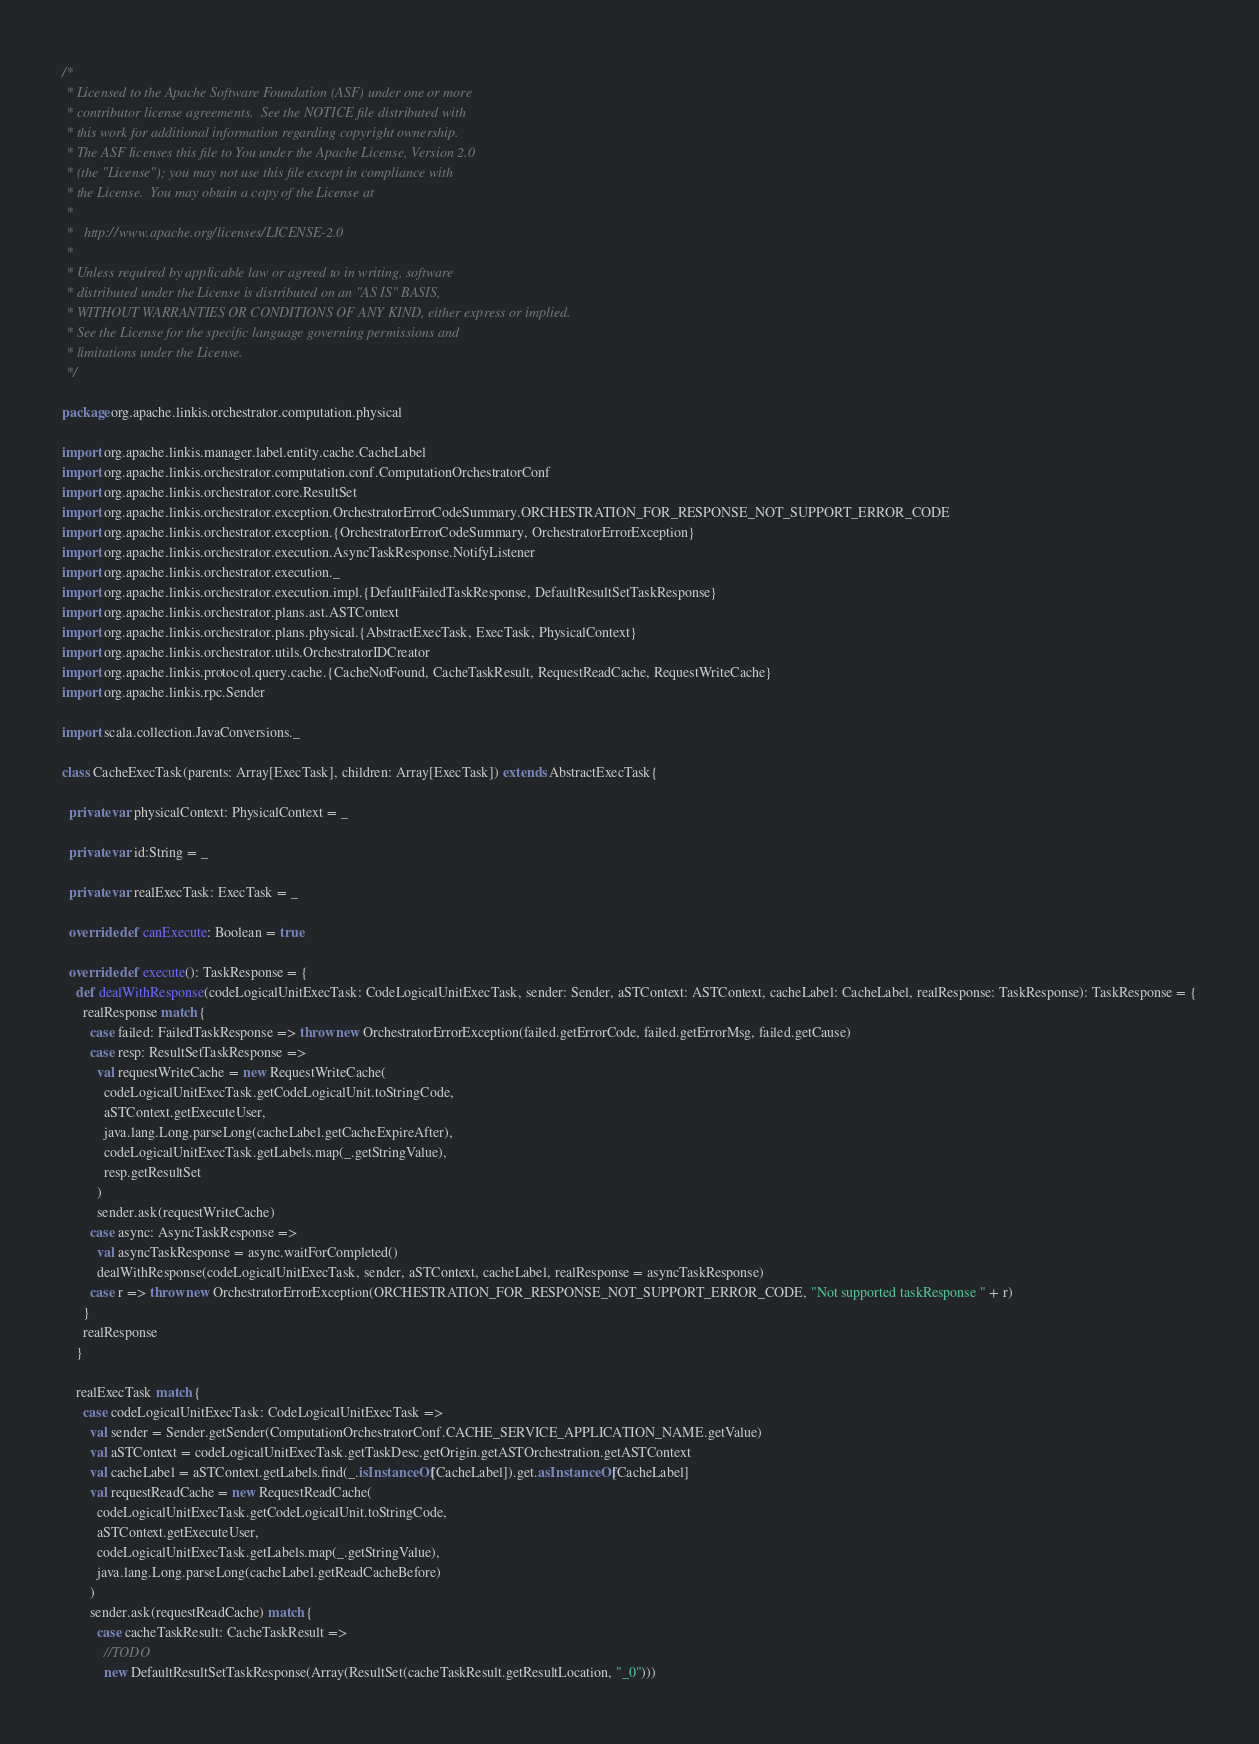<code> <loc_0><loc_0><loc_500><loc_500><_Scala_>/*
 * Licensed to the Apache Software Foundation (ASF) under one or more
 * contributor license agreements.  See the NOTICE file distributed with
 * this work for additional information regarding copyright ownership.
 * The ASF licenses this file to You under the Apache License, Version 2.0
 * (the "License"); you may not use this file except in compliance with
 * the License.  You may obtain a copy of the License at
 * 
 *   http://www.apache.org/licenses/LICENSE-2.0
 * 
 * Unless required by applicable law or agreed to in writing, software
 * distributed under the License is distributed on an "AS IS" BASIS,
 * WITHOUT WARRANTIES OR CONDITIONS OF ANY KIND, either express or implied.
 * See the License for the specific language governing permissions and
 * limitations under the License.
 */
 
package org.apache.linkis.orchestrator.computation.physical

import org.apache.linkis.manager.label.entity.cache.CacheLabel
import org.apache.linkis.orchestrator.computation.conf.ComputationOrchestratorConf
import org.apache.linkis.orchestrator.core.ResultSet
import org.apache.linkis.orchestrator.exception.OrchestratorErrorCodeSummary.ORCHESTRATION_FOR_RESPONSE_NOT_SUPPORT_ERROR_CODE
import org.apache.linkis.orchestrator.exception.{OrchestratorErrorCodeSummary, OrchestratorErrorException}
import org.apache.linkis.orchestrator.execution.AsyncTaskResponse.NotifyListener
import org.apache.linkis.orchestrator.execution._
import org.apache.linkis.orchestrator.execution.impl.{DefaultFailedTaskResponse, DefaultResultSetTaskResponse}
import org.apache.linkis.orchestrator.plans.ast.ASTContext
import org.apache.linkis.orchestrator.plans.physical.{AbstractExecTask, ExecTask, PhysicalContext}
import org.apache.linkis.orchestrator.utils.OrchestratorIDCreator
import org.apache.linkis.protocol.query.cache.{CacheNotFound, CacheTaskResult, RequestReadCache, RequestWriteCache}
import org.apache.linkis.rpc.Sender

import scala.collection.JavaConversions._

class CacheExecTask(parents: Array[ExecTask], children: Array[ExecTask]) extends AbstractExecTask{

  private var physicalContext: PhysicalContext = _

  private var id:String = _

  private var realExecTask: ExecTask = _

  override def canExecute: Boolean = true

  override def execute(): TaskResponse = {
    def dealWithResponse(codeLogicalUnitExecTask: CodeLogicalUnitExecTask, sender: Sender, aSTContext: ASTContext, cacheLabel: CacheLabel, realResponse: TaskResponse): TaskResponse = {
      realResponse match {
        case failed: FailedTaskResponse => throw new OrchestratorErrorException(failed.getErrorCode, failed.getErrorMsg, failed.getCause)
        case resp: ResultSetTaskResponse =>
          val requestWriteCache = new RequestWriteCache(
            codeLogicalUnitExecTask.getCodeLogicalUnit.toStringCode,
            aSTContext.getExecuteUser,
            java.lang.Long.parseLong(cacheLabel.getCacheExpireAfter),
            codeLogicalUnitExecTask.getLabels.map(_.getStringValue),
            resp.getResultSet
          )
          sender.ask(requestWriteCache)
        case async: AsyncTaskResponse =>
          val asyncTaskResponse = async.waitForCompleted()
          dealWithResponse(codeLogicalUnitExecTask, sender, aSTContext, cacheLabel, realResponse = asyncTaskResponse)
        case r => throw new OrchestratorErrorException(ORCHESTRATION_FOR_RESPONSE_NOT_SUPPORT_ERROR_CODE, "Not supported taskResponse " + r)
      }
      realResponse
    }

    realExecTask match {
      case codeLogicalUnitExecTask: CodeLogicalUnitExecTask =>
        val sender = Sender.getSender(ComputationOrchestratorConf.CACHE_SERVICE_APPLICATION_NAME.getValue)
        val aSTContext = codeLogicalUnitExecTask.getTaskDesc.getOrigin.getASTOrchestration.getASTContext
        val cacheLabel = aSTContext.getLabels.find(_.isInstanceOf[CacheLabel]).get.asInstanceOf[CacheLabel]
        val requestReadCache = new RequestReadCache(
          codeLogicalUnitExecTask.getCodeLogicalUnit.toStringCode,
          aSTContext.getExecuteUser,
          codeLogicalUnitExecTask.getLabels.map(_.getStringValue),
          java.lang.Long.parseLong(cacheLabel.getReadCacheBefore)
        )
        sender.ask(requestReadCache) match {
          case cacheTaskResult: CacheTaskResult =>
            //TODO
            new DefaultResultSetTaskResponse(Array(ResultSet(cacheTaskResult.getResultLocation, "_0")))</code> 